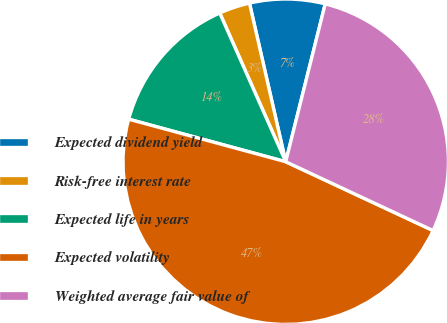Convert chart to OTSL. <chart><loc_0><loc_0><loc_500><loc_500><pie_chart><fcel>Expected dividend yield<fcel>Risk-free interest rate<fcel>Expected life in years<fcel>Expected volatility<fcel>Weighted average fair value of<nl><fcel>7.48%<fcel>3.07%<fcel>14.14%<fcel>47.25%<fcel>28.05%<nl></chart> 